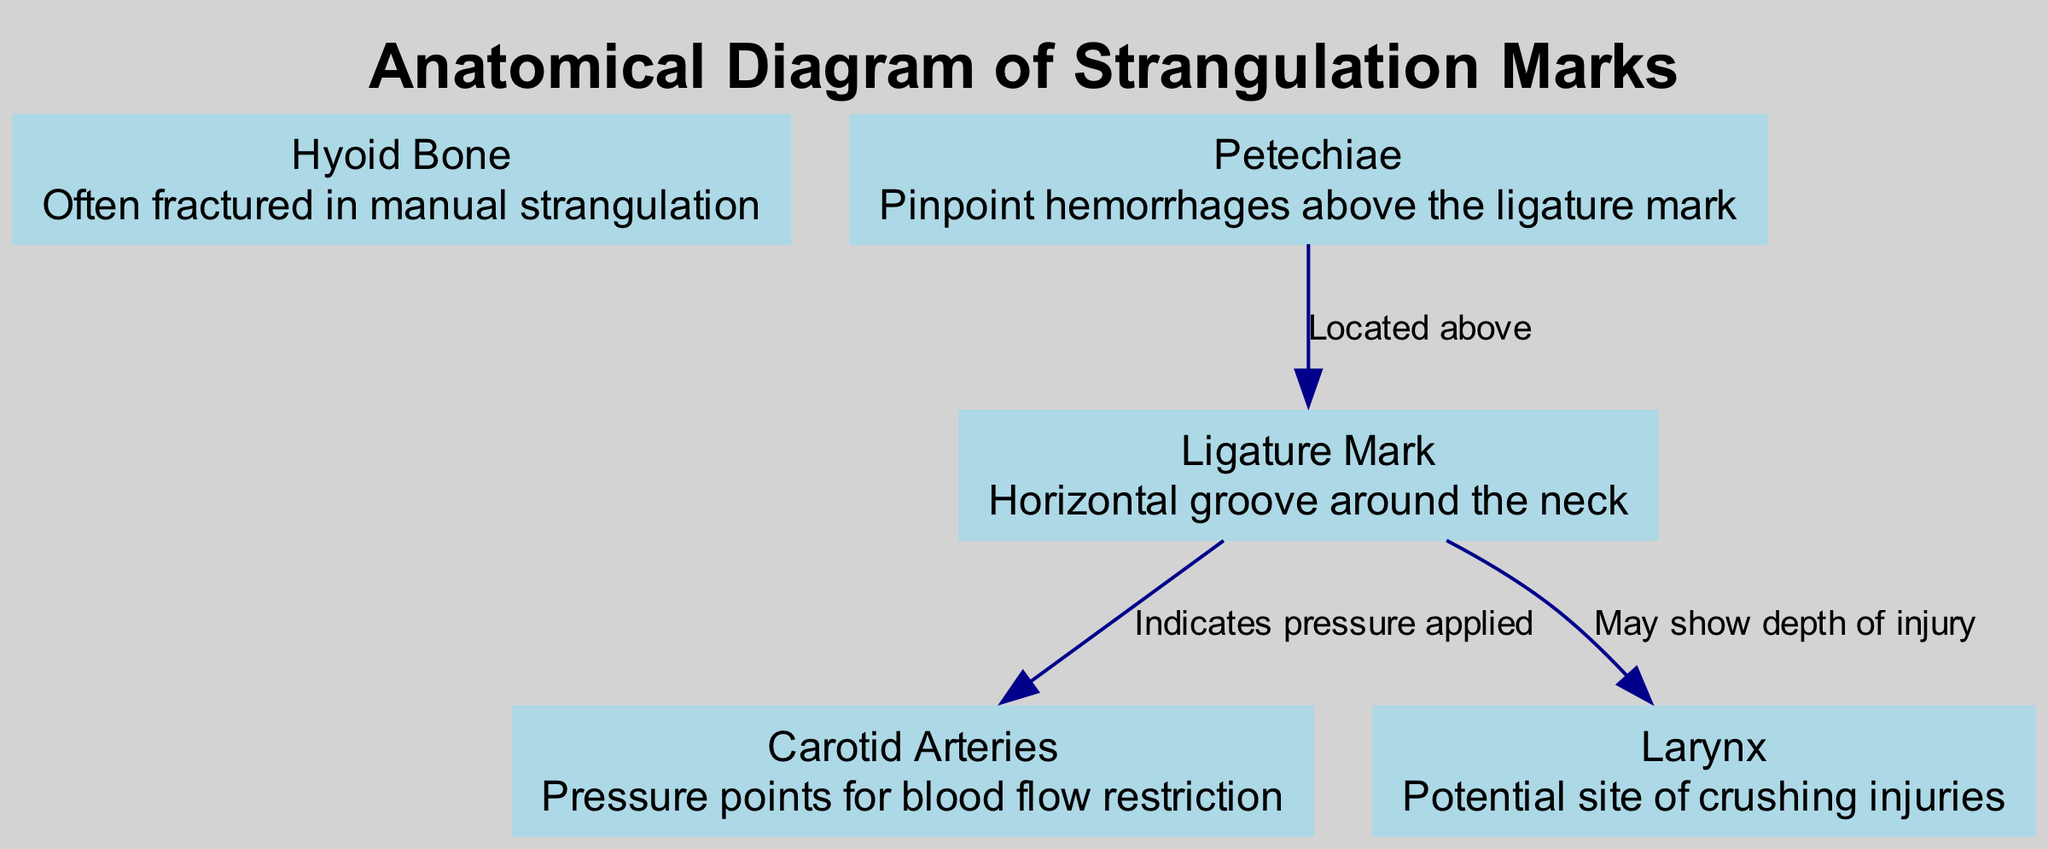What is the title of the diagram? The title in the diagram is specified at the top as "Anatomical Diagram of Strangulation Marks."
Answer: Anatomical Diagram of Strangulation Marks How many nodes are in the diagram? Counting the nodes listed in the data, there are five distinct nodes representing different anatomical components related to strangulation marks.
Answer: 5 Which node is described as "often fractured in manual strangulation"? By reviewing the descriptions of each node, the "Hyoid Bone" is specified as often fractured in cases of manual strangulation.
Answer: Hyoid Bone What does the edge from "Ligature Mark" to "Carotid Arteries" indicate? The edge connecting "Ligature Mark" to "Carotid Arteries" signifies that pressure is applied, affecting blood flow restriction in that area.
Answer: Indicates pressure applied Where are Petechiae located in relation to the Ligature Mark? The description indicates that Petechiae are found above the Ligature Mark, implying their positioning on the neck relative to where the ligature mark resides.
Answer: Above What is the potential site of crushing injuries? Referring to the specific nodes, the "Larynx" is indicated as the potential site where crushing injuries can occur in strangulation cases.
Answer: Larynx What anatomical structure is highlighted for blood flow restriction? The "Carotid Arteries" are highlighted specifically for their critical role in blood flow restriction during strangulation scenarios.
Answer: Carotid Arteries What type of injuries does the Hyoid Bone typically sustain? The description states that the Hyoid Bone typically sustains fractures, making it a key focus in cases of manual strangulation.
Answer: Fractured Explain the significance of the relationship between Petechiae and Ligature Mark. The diagram shows that Petechiae, which are pinpoint hemorrhages, are located above the Ligature Mark, indicating they arise due to trauma caused by the ligature compressing blood vessels. This relationship emphasizes how local trauma can lead to vascular damage above the direct point of strangulation.
Answer: Pinpoint hemorrhages above the ligature mark 